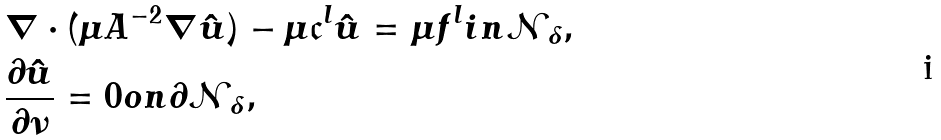<formula> <loc_0><loc_0><loc_500><loc_500>& \nabla \cdot ( \mu A ^ { - 2 } \nabla \hat { u } ) - \mu \mathfrak { c } ^ { l } \hat { u } = \mu f ^ { l } i n \mathcal { N } _ { \delta } , \\ & \frac { \partial \hat { u } } { \partial \nu } = 0 o n \partial \mathcal { N } _ { \delta } ,</formula> 